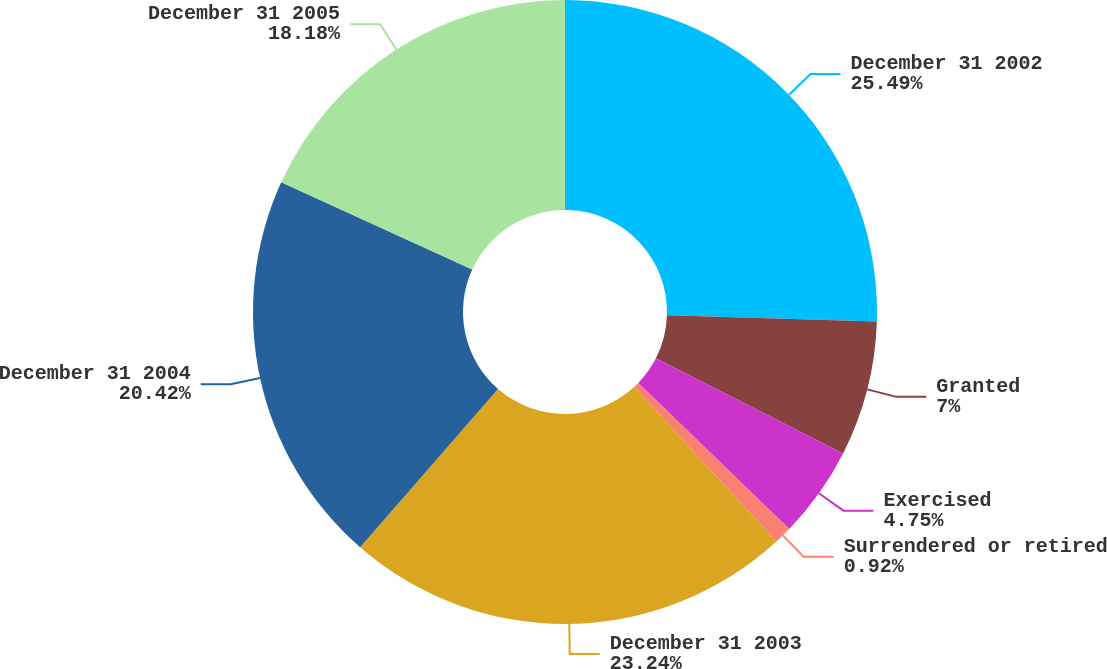Convert chart to OTSL. <chart><loc_0><loc_0><loc_500><loc_500><pie_chart><fcel>December 31 2002<fcel>Granted<fcel>Exercised<fcel>Surrendered or retired<fcel>December 31 2003<fcel>December 31 2004<fcel>December 31 2005<nl><fcel>25.49%<fcel>7.0%<fcel>4.75%<fcel>0.92%<fcel>23.24%<fcel>20.42%<fcel>18.18%<nl></chart> 